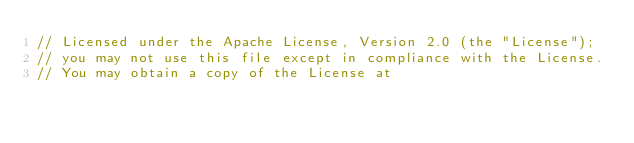<code> <loc_0><loc_0><loc_500><loc_500><_JavaScript_>// Licensed under the Apache License, Version 2.0 (the "License");
// you may not use this file except in compliance with the License.
// You may obtain a copy of the License at</code> 